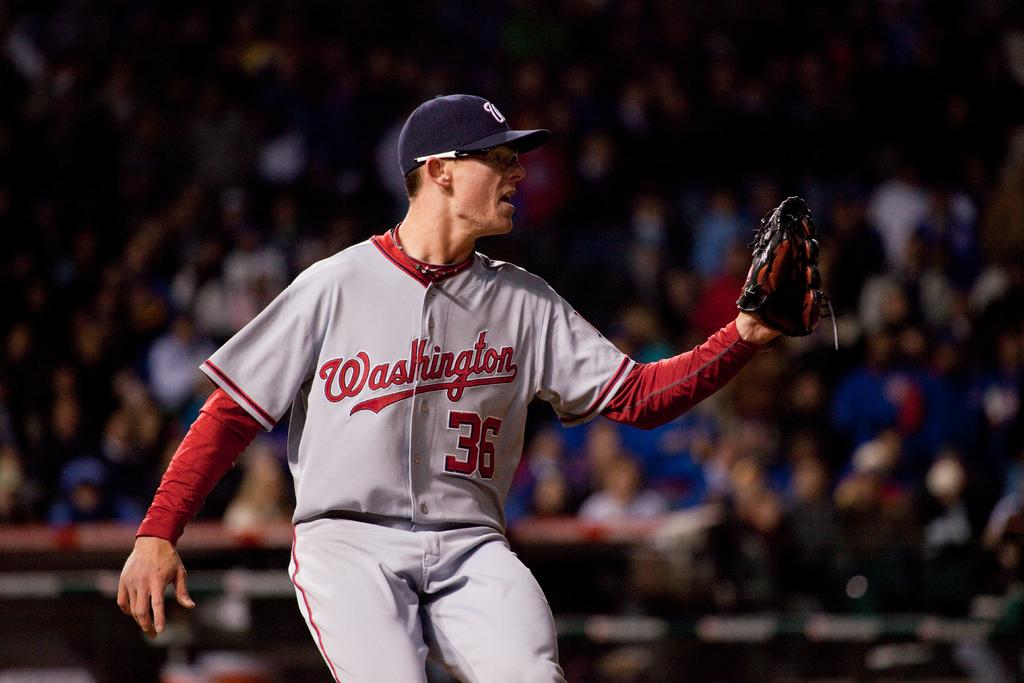Who is the main subject in the image? There is a man in the image. What is the man doing in the image? The man is in motion. What accessories is the man wearing in the image? The man is wearing gloves and a cap. What can be observed about the background of the image? The background of the image is blurry. Are there any other people visible in the image? Yes, there are people visible in the background of the image. What type of sand can be seen in the image? There is no sand present in the image. What knowledge does the man possess about the subject he is discussing in the image? The image does not provide any information about the man's knowledge or the subject he is discussing. 